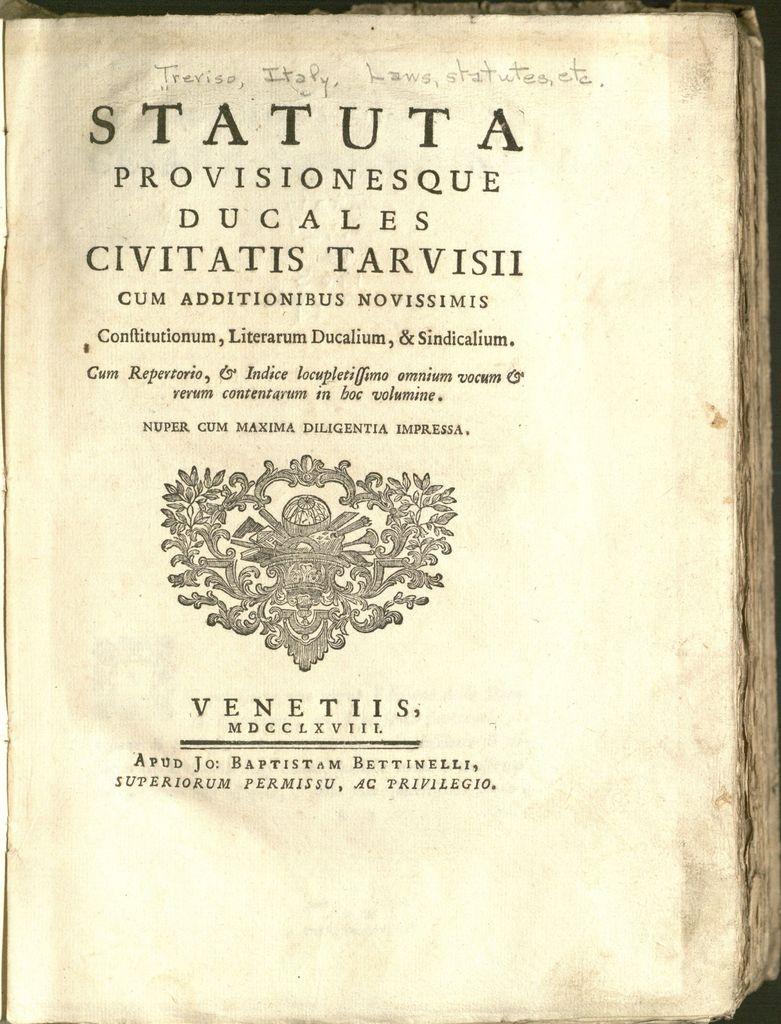What is the first word of the title?
Ensure brevity in your answer.  Statuta. 